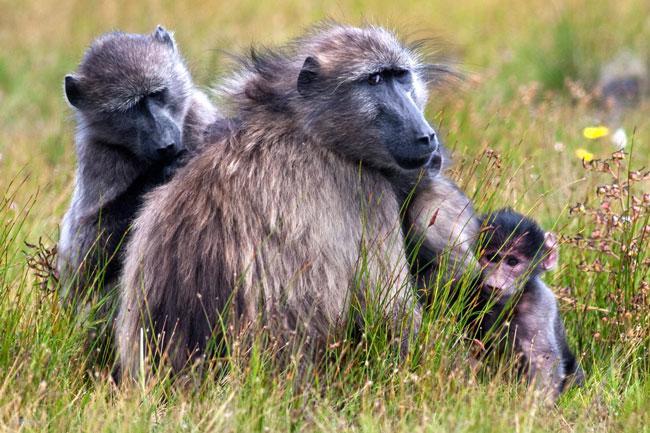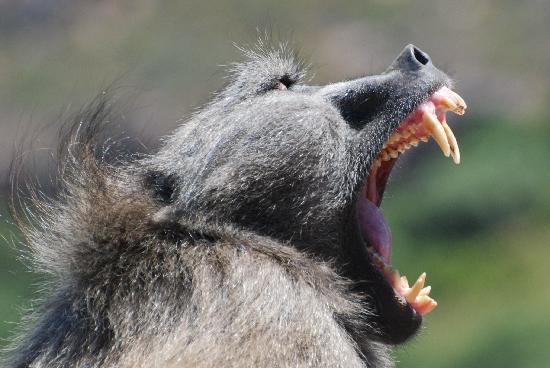The first image is the image on the left, the second image is the image on the right. Assess this claim about the two images: "One image shows the face of a fang-baring baboon in profile, and the other image includes a baby baboon.". Correct or not? Answer yes or no. Yes. The first image is the image on the left, the second image is the image on the right. Considering the images on both sides, is "In one image there is an adult monkey holding onto food with a young monkey nearby." valid? Answer yes or no. No. 